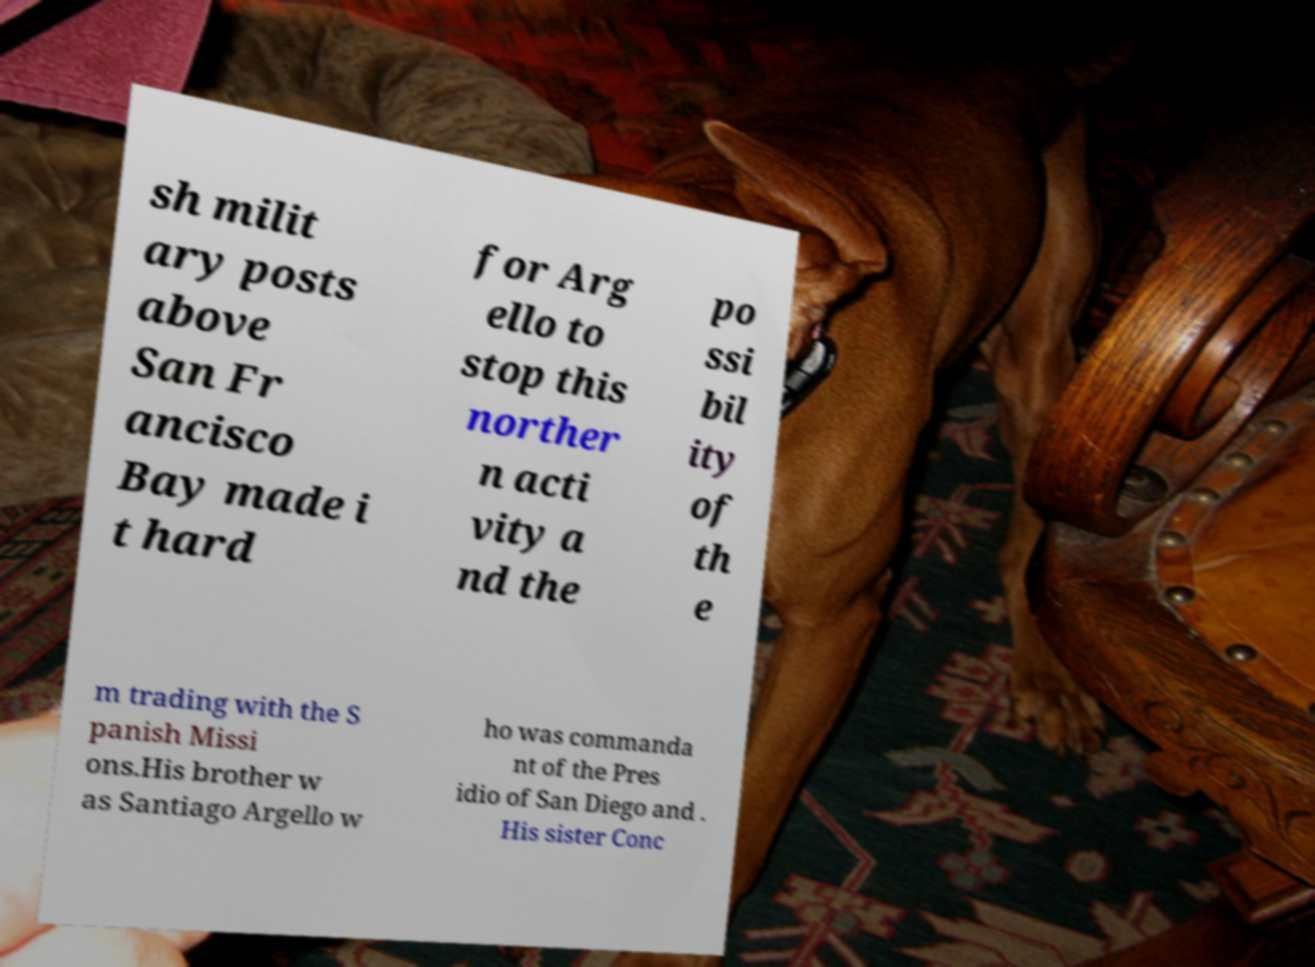Can you accurately transcribe the text from the provided image for me? sh milit ary posts above San Fr ancisco Bay made i t hard for Arg ello to stop this norther n acti vity a nd the po ssi bil ity of th e m trading with the S panish Missi ons.His brother w as Santiago Argello w ho was commanda nt of the Pres idio of San Diego and . His sister Conc 